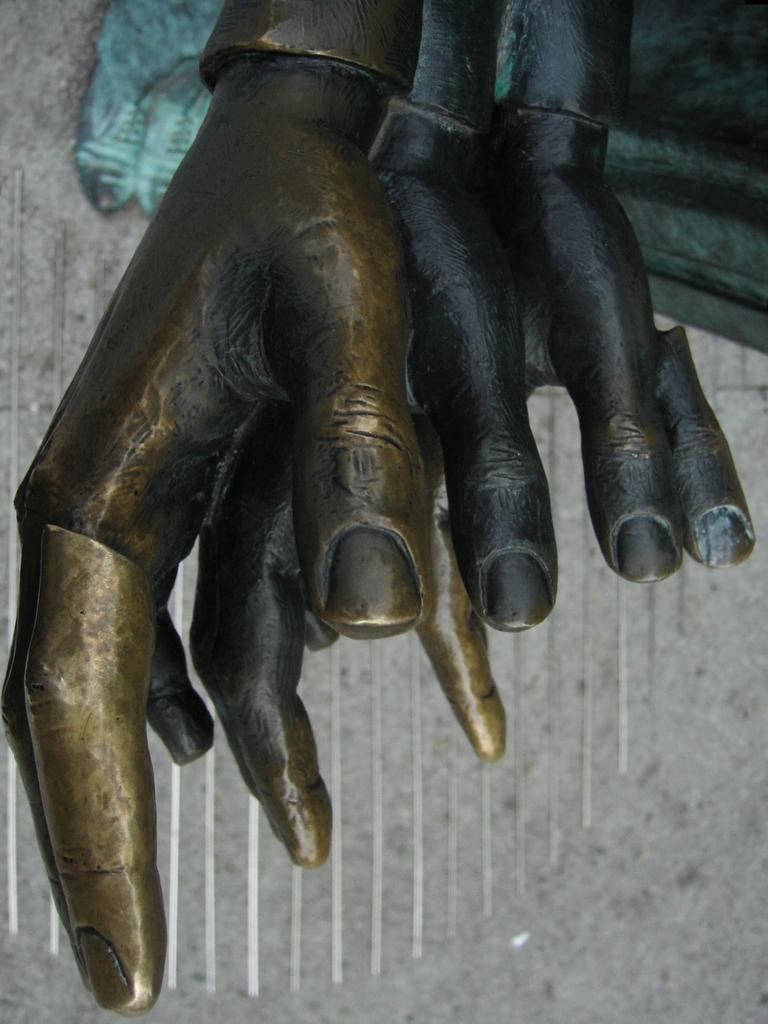How would you summarize this image in a sentence or two? In this picture we can see sculpture. 